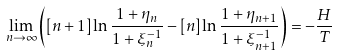<formula> <loc_0><loc_0><loc_500><loc_500>\lim _ { n \rightarrow \infty } \left ( \left [ n + 1 \right ] \ln \frac { 1 + \eta _ { n } } { 1 + \xi _ { n } ^ { - 1 } } - \left [ n \right ] \ln \frac { 1 + \eta _ { n + 1 } } { 1 + \xi _ { n + 1 } ^ { - 1 } } \right ) = - \frac { H } { T }</formula> 